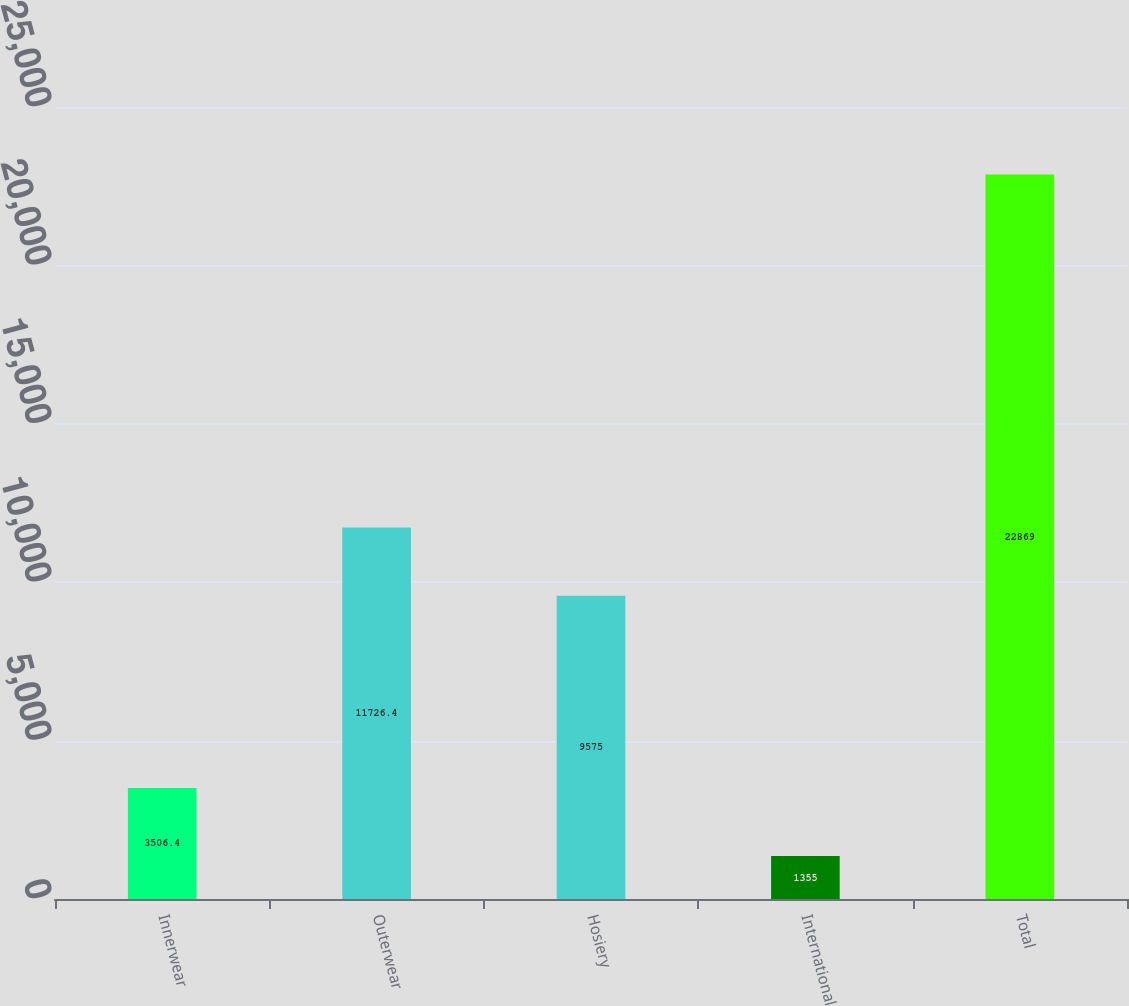Convert chart to OTSL. <chart><loc_0><loc_0><loc_500><loc_500><bar_chart><fcel>Innerwear<fcel>Outerwear<fcel>Hosiery<fcel>International<fcel>Total<nl><fcel>3506.4<fcel>11726.4<fcel>9575<fcel>1355<fcel>22869<nl></chart> 